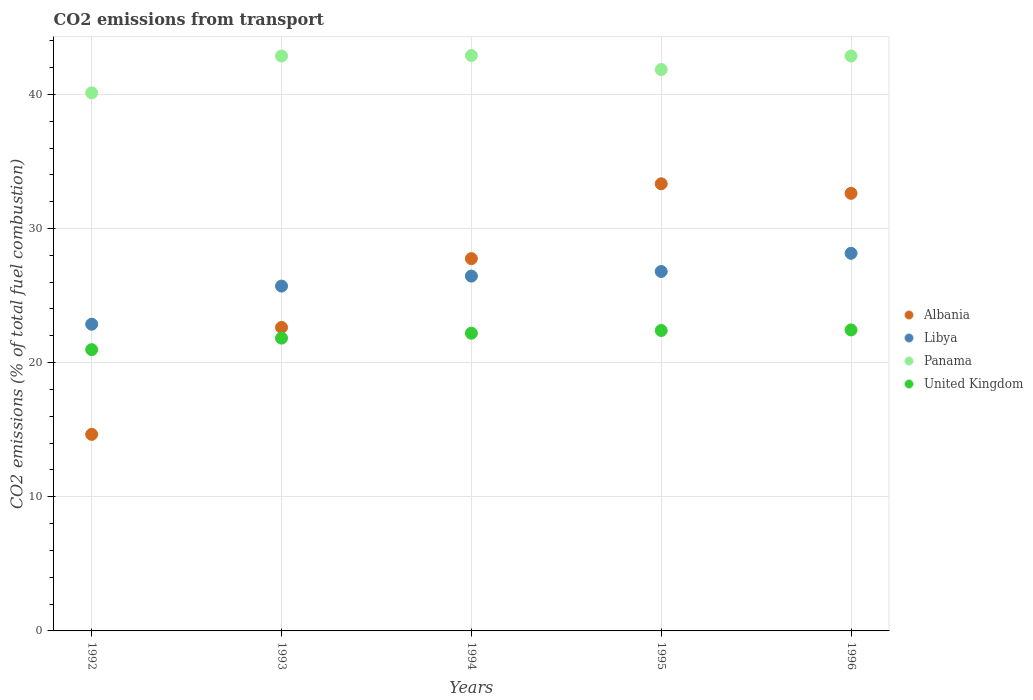What is the total CO2 emitted in Libya in 1994?
Offer a very short reply. 26.45. Across all years, what is the maximum total CO2 emitted in Albania?
Offer a terse response. 33.33. Across all years, what is the minimum total CO2 emitted in Panama?
Offer a terse response. 40.11. In which year was the total CO2 emitted in Libya maximum?
Ensure brevity in your answer.  1996. What is the total total CO2 emitted in Panama in the graph?
Give a very brief answer. 210.57. What is the difference between the total CO2 emitted in Libya in 1994 and that in 1996?
Make the answer very short. -1.7. What is the difference between the total CO2 emitted in Panama in 1993 and the total CO2 emitted in Albania in 1995?
Ensure brevity in your answer.  9.52. What is the average total CO2 emitted in United Kingdom per year?
Ensure brevity in your answer.  21.96. In the year 1992, what is the difference between the total CO2 emitted in United Kingdom and total CO2 emitted in Libya?
Your response must be concise. -1.9. What is the ratio of the total CO2 emitted in Panama in 1995 to that in 1996?
Keep it short and to the point. 0.98. Is the difference between the total CO2 emitted in United Kingdom in 1992 and 1995 greater than the difference between the total CO2 emitted in Libya in 1992 and 1995?
Provide a succinct answer. Yes. What is the difference between the highest and the second highest total CO2 emitted in Albania?
Your answer should be compact. 0.71. What is the difference between the highest and the lowest total CO2 emitted in Panama?
Offer a terse response. 2.78. Is it the case that in every year, the sum of the total CO2 emitted in United Kingdom and total CO2 emitted in Panama  is greater than the total CO2 emitted in Libya?
Your response must be concise. Yes. How many years are there in the graph?
Provide a short and direct response. 5. What is the difference between two consecutive major ticks on the Y-axis?
Your response must be concise. 10. Are the values on the major ticks of Y-axis written in scientific E-notation?
Provide a succinct answer. No. Does the graph contain grids?
Provide a short and direct response. Yes. How many legend labels are there?
Provide a short and direct response. 4. What is the title of the graph?
Keep it short and to the point. CO2 emissions from transport. Does "Canada" appear as one of the legend labels in the graph?
Make the answer very short. No. What is the label or title of the Y-axis?
Make the answer very short. CO2 emissions (% of total fuel combustion). What is the CO2 emissions (% of total fuel combustion) of Albania in 1992?
Your response must be concise. 14.65. What is the CO2 emissions (% of total fuel combustion) of Libya in 1992?
Your answer should be compact. 22.86. What is the CO2 emissions (% of total fuel combustion) of Panama in 1992?
Your answer should be very brief. 40.11. What is the CO2 emissions (% of total fuel combustion) in United Kingdom in 1992?
Make the answer very short. 20.97. What is the CO2 emissions (% of total fuel combustion) in Albania in 1993?
Give a very brief answer. 22.62. What is the CO2 emissions (% of total fuel combustion) of Libya in 1993?
Provide a short and direct response. 25.71. What is the CO2 emissions (% of total fuel combustion) of Panama in 1993?
Provide a succinct answer. 42.86. What is the CO2 emissions (% of total fuel combustion) of United Kingdom in 1993?
Your response must be concise. 21.83. What is the CO2 emissions (% of total fuel combustion) of Albania in 1994?
Ensure brevity in your answer.  27.75. What is the CO2 emissions (% of total fuel combustion) in Libya in 1994?
Offer a terse response. 26.45. What is the CO2 emissions (% of total fuel combustion) of Panama in 1994?
Offer a terse response. 42.89. What is the CO2 emissions (% of total fuel combustion) of United Kingdom in 1994?
Keep it short and to the point. 22.19. What is the CO2 emissions (% of total fuel combustion) in Albania in 1995?
Your response must be concise. 33.33. What is the CO2 emissions (% of total fuel combustion) in Libya in 1995?
Keep it short and to the point. 26.79. What is the CO2 emissions (% of total fuel combustion) of Panama in 1995?
Offer a very short reply. 41.85. What is the CO2 emissions (% of total fuel combustion) in United Kingdom in 1995?
Give a very brief answer. 22.4. What is the CO2 emissions (% of total fuel combustion) in Albania in 1996?
Ensure brevity in your answer.  32.62. What is the CO2 emissions (% of total fuel combustion) in Libya in 1996?
Provide a short and direct response. 28.15. What is the CO2 emissions (% of total fuel combustion) of Panama in 1996?
Give a very brief answer. 42.86. What is the CO2 emissions (% of total fuel combustion) in United Kingdom in 1996?
Make the answer very short. 22.44. Across all years, what is the maximum CO2 emissions (% of total fuel combustion) in Albania?
Offer a terse response. 33.33. Across all years, what is the maximum CO2 emissions (% of total fuel combustion) in Libya?
Offer a very short reply. 28.15. Across all years, what is the maximum CO2 emissions (% of total fuel combustion) of Panama?
Give a very brief answer. 42.89. Across all years, what is the maximum CO2 emissions (% of total fuel combustion) of United Kingdom?
Ensure brevity in your answer.  22.44. Across all years, what is the minimum CO2 emissions (% of total fuel combustion) in Albania?
Your answer should be very brief. 14.65. Across all years, what is the minimum CO2 emissions (% of total fuel combustion) in Libya?
Make the answer very short. 22.86. Across all years, what is the minimum CO2 emissions (% of total fuel combustion) of Panama?
Your answer should be compact. 40.11. Across all years, what is the minimum CO2 emissions (% of total fuel combustion) of United Kingdom?
Give a very brief answer. 20.97. What is the total CO2 emissions (% of total fuel combustion) of Albania in the graph?
Keep it short and to the point. 130.98. What is the total CO2 emissions (% of total fuel combustion) of Libya in the graph?
Provide a short and direct response. 129.97. What is the total CO2 emissions (% of total fuel combustion) of Panama in the graph?
Keep it short and to the point. 210.57. What is the total CO2 emissions (% of total fuel combustion) of United Kingdom in the graph?
Keep it short and to the point. 109.82. What is the difference between the CO2 emissions (% of total fuel combustion) of Albania in 1992 and that in 1993?
Keep it short and to the point. -7.97. What is the difference between the CO2 emissions (% of total fuel combustion) in Libya in 1992 and that in 1993?
Provide a short and direct response. -2.84. What is the difference between the CO2 emissions (% of total fuel combustion) of Panama in 1992 and that in 1993?
Your answer should be compact. -2.74. What is the difference between the CO2 emissions (% of total fuel combustion) of United Kingdom in 1992 and that in 1993?
Provide a succinct answer. -0.86. What is the difference between the CO2 emissions (% of total fuel combustion) of Albania in 1992 and that in 1994?
Offer a terse response. -13.1. What is the difference between the CO2 emissions (% of total fuel combustion) in Libya in 1992 and that in 1994?
Your answer should be very brief. -3.59. What is the difference between the CO2 emissions (% of total fuel combustion) of Panama in 1992 and that in 1994?
Your answer should be compact. -2.78. What is the difference between the CO2 emissions (% of total fuel combustion) in United Kingdom in 1992 and that in 1994?
Your answer should be very brief. -1.23. What is the difference between the CO2 emissions (% of total fuel combustion) of Albania in 1992 and that in 1995?
Your answer should be very brief. -18.68. What is the difference between the CO2 emissions (% of total fuel combustion) of Libya in 1992 and that in 1995?
Your response must be concise. -3.93. What is the difference between the CO2 emissions (% of total fuel combustion) of Panama in 1992 and that in 1995?
Keep it short and to the point. -1.74. What is the difference between the CO2 emissions (% of total fuel combustion) of United Kingdom in 1992 and that in 1995?
Provide a succinct answer. -1.43. What is the difference between the CO2 emissions (% of total fuel combustion) of Albania in 1992 and that in 1996?
Provide a short and direct response. -17.97. What is the difference between the CO2 emissions (% of total fuel combustion) in Libya in 1992 and that in 1996?
Your response must be concise. -5.29. What is the difference between the CO2 emissions (% of total fuel combustion) of Panama in 1992 and that in 1996?
Your response must be concise. -2.74. What is the difference between the CO2 emissions (% of total fuel combustion) in United Kingdom in 1992 and that in 1996?
Your response must be concise. -1.47. What is the difference between the CO2 emissions (% of total fuel combustion) of Albania in 1993 and that in 1994?
Make the answer very short. -5.13. What is the difference between the CO2 emissions (% of total fuel combustion) in Libya in 1993 and that in 1994?
Provide a succinct answer. -0.74. What is the difference between the CO2 emissions (% of total fuel combustion) of Panama in 1993 and that in 1994?
Provide a succinct answer. -0.04. What is the difference between the CO2 emissions (% of total fuel combustion) in United Kingdom in 1993 and that in 1994?
Give a very brief answer. -0.37. What is the difference between the CO2 emissions (% of total fuel combustion) of Albania in 1993 and that in 1995?
Your response must be concise. -10.71. What is the difference between the CO2 emissions (% of total fuel combustion) of Libya in 1993 and that in 1995?
Offer a very short reply. -1.09. What is the difference between the CO2 emissions (% of total fuel combustion) of United Kingdom in 1993 and that in 1995?
Ensure brevity in your answer.  -0.57. What is the difference between the CO2 emissions (% of total fuel combustion) of Albania in 1993 and that in 1996?
Your response must be concise. -10. What is the difference between the CO2 emissions (% of total fuel combustion) in Libya in 1993 and that in 1996?
Your answer should be very brief. -2.44. What is the difference between the CO2 emissions (% of total fuel combustion) of United Kingdom in 1993 and that in 1996?
Give a very brief answer. -0.61. What is the difference between the CO2 emissions (% of total fuel combustion) in Albania in 1994 and that in 1995?
Make the answer very short. -5.58. What is the difference between the CO2 emissions (% of total fuel combustion) of Libya in 1994 and that in 1995?
Give a very brief answer. -0.34. What is the difference between the CO2 emissions (% of total fuel combustion) in Panama in 1994 and that in 1995?
Provide a short and direct response. 1.05. What is the difference between the CO2 emissions (% of total fuel combustion) in United Kingdom in 1994 and that in 1995?
Your answer should be compact. -0.2. What is the difference between the CO2 emissions (% of total fuel combustion) in Albania in 1994 and that in 1996?
Offer a very short reply. -4.87. What is the difference between the CO2 emissions (% of total fuel combustion) of Libya in 1994 and that in 1996?
Keep it short and to the point. -1.7. What is the difference between the CO2 emissions (% of total fuel combustion) in Panama in 1994 and that in 1996?
Give a very brief answer. 0.04. What is the difference between the CO2 emissions (% of total fuel combustion) in United Kingdom in 1994 and that in 1996?
Offer a very short reply. -0.25. What is the difference between the CO2 emissions (% of total fuel combustion) in Albania in 1995 and that in 1996?
Offer a terse response. 0.71. What is the difference between the CO2 emissions (% of total fuel combustion) in Libya in 1995 and that in 1996?
Give a very brief answer. -1.36. What is the difference between the CO2 emissions (% of total fuel combustion) in Panama in 1995 and that in 1996?
Provide a short and direct response. -1.01. What is the difference between the CO2 emissions (% of total fuel combustion) of United Kingdom in 1995 and that in 1996?
Ensure brevity in your answer.  -0.04. What is the difference between the CO2 emissions (% of total fuel combustion) of Albania in 1992 and the CO2 emissions (% of total fuel combustion) of Libya in 1993?
Your answer should be very brief. -11.06. What is the difference between the CO2 emissions (% of total fuel combustion) in Albania in 1992 and the CO2 emissions (% of total fuel combustion) in Panama in 1993?
Keep it short and to the point. -28.21. What is the difference between the CO2 emissions (% of total fuel combustion) in Albania in 1992 and the CO2 emissions (% of total fuel combustion) in United Kingdom in 1993?
Your answer should be very brief. -7.17. What is the difference between the CO2 emissions (% of total fuel combustion) of Libya in 1992 and the CO2 emissions (% of total fuel combustion) of Panama in 1993?
Make the answer very short. -19.99. What is the difference between the CO2 emissions (% of total fuel combustion) of Libya in 1992 and the CO2 emissions (% of total fuel combustion) of United Kingdom in 1993?
Offer a terse response. 1.04. What is the difference between the CO2 emissions (% of total fuel combustion) in Panama in 1992 and the CO2 emissions (% of total fuel combustion) in United Kingdom in 1993?
Give a very brief answer. 18.29. What is the difference between the CO2 emissions (% of total fuel combustion) in Albania in 1992 and the CO2 emissions (% of total fuel combustion) in Libya in 1994?
Provide a succinct answer. -11.8. What is the difference between the CO2 emissions (% of total fuel combustion) in Albania in 1992 and the CO2 emissions (% of total fuel combustion) in Panama in 1994?
Your answer should be very brief. -28.24. What is the difference between the CO2 emissions (% of total fuel combustion) of Albania in 1992 and the CO2 emissions (% of total fuel combustion) of United Kingdom in 1994?
Provide a short and direct response. -7.54. What is the difference between the CO2 emissions (% of total fuel combustion) of Libya in 1992 and the CO2 emissions (% of total fuel combustion) of Panama in 1994?
Ensure brevity in your answer.  -20.03. What is the difference between the CO2 emissions (% of total fuel combustion) in Libya in 1992 and the CO2 emissions (% of total fuel combustion) in United Kingdom in 1994?
Keep it short and to the point. 0.67. What is the difference between the CO2 emissions (% of total fuel combustion) of Panama in 1992 and the CO2 emissions (% of total fuel combustion) of United Kingdom in 1994?
Your response must be concise. 17.92. What is the difference between the CO2 emissions (% of total fuel combustion) in Albania in 1992 and the CO2 emissions (% of total fuel combustion) in Libya in 1995?
Ensure brevity in your answer.  -12.14. What is the difference between the CO2 emissions (% of total fuel combustion) in Albania in 1992 and the CO2 emissions (% of total fuel combustion) in Panama in 1995?
Provide a short and direct response. -27.2. What is the difference between the CO2 emissions (% of total fuel combustion) of Albania in 1992 and the CO2 emissions (% of total fuel combustion) of United Kingdom in 1995?
Ensure brevity in your answer.  -7.74. What is the difference between the CO2 emissions (% of total fuel combustion) in Libya in 1992 and the CO2 emissions (% of total fuel combustion) in Panama in 1995?
Keep it short and to the point. -18.99. What is the difference between the CO2 emissions (% of total fuel combustion) in Libya in 1992 and the CO2 emissions (% of total fuel combustion) in United Kingdom in 1995?
Your answer should be compact. 0.47. What is the difference between the CO2 emissions (% of total fuel combustion) of Panama in 1992 and the CO2 emissions (% of total fuel combustion) of United Kingdom in 1995?
Make the answer very short. 17.72. What is the difference between the CO2 emissions (% of total fuel combustion) in Albania in 1992 and the CO2 emissions (% of total fuel combustion) in Libya in 1996?
Provide a succinct answer. -13.5. What is the difference between the CO2 emissions (% of total fuel combustion) in Albania in 1992 and the CO2 emissions (% of total fuel combustion) in Panama in 1996?
Offer a very short reply. -28.21. What is the difference between the CO2 emissions (% of total fuel combustion) in Albania in 1992 and the CO2 emissions (% of total fuel combustion) in United Kingdom in 1996?
Your response must be concise. -7.79. What is the difference between the CO2 emissions (% of total fuel combustion) in Libya in 1992 and the CO2 emissions (% of total fuel combustion) in Panama in 1996?
Your response must be concise. -19.99. What is the difference between the CO2 emissions (% of total fuel combustion) in Libya in 1992 and the CO2 emissions (% of total fuel combustion) in United Kingdom in 1996?
Provide a succinct answer. 0.42. What is the difference between the CO2 emissions (% of total fuel combustion) in Panama in 1992 and the CO2 emissions (% of total fuel combustion) in United Kingdom in 1996?
Give a very brief answer. 17.67. What is the difference between the CO2 emissions (% of total fuel combustion) of Albania in 1993 and the CO2 emissions (% of total fuel combustion) of Libya in 1994?
Make the answer very short. -3.83. What is the difference between the CO2 emissions (% of total fuel combustion) in Albania in 1993 and the CO2 emissions (% of total fuel combustion) in Panama in 1994?
Provide a succinct answer. -20.27. What is the difference between the CO2 emissions (% of total fuel combustion) in Albania in 1993 and the CO2 emissions (% of total fuel combustion) in United Kingdom in 1994?
Offer a terse response. 0.43. What is the difference between the CO2 emissions (% of total fuel combustion) in Libya in 1993 and the CO2 emissions (% of total fuel combustion) in Panama in 1994?
Provide a short and direct response. -17.19. What is the difference between the CO2 emissions (% of total fuel combustion) in Libya in 1993 and the CO2 emissions (% of total fuel combustion) in United Kingdom in 1994?
Your response must be concise. 3.51. What is the difference between the CO2 emissions (% of total fuel combustion) of Panama in 1993 and the CO2 emissions (% of total fuel combustion) of United Kingdom in 1994?
Provide a short and direct response. 20.66. What is the difference between the CO2 emissions (% of total fuel combustion) of Albania in 1993 and the CO2 emissions (% of total fuel combustion) of Libya in 1995?
Offer a very short reply. -4.17. What is the difference between the CO2 emissions (% of total fuel combustion) of Albania in 1993 and the CO2 emissions (% of total fuel combustion) of Panama in 1995?
Provide a short and direct response. -19.22. What is the difference between the CO2 emissions (% of total fuel combustion) in Albania in 1993 and the CO2 emissions (% of total fuel combustion) in United Kingdom in 1995?
Provide a short and direct response. 0.23. What is the difference between the CO2 emissions (% of total fuel combustion) in Libya in 1993 and the CO2 emissions (% of total fuel combustion) in Panama in 1995?
Your answer should be compact. -16.14. What is the difference between the CO2 emissions (% of total fuel combustion) in Libya in 1993 and the CO2 emissions (% of total fuel combustion) in United Kingdom in 1995?
Your answer should be very brief. 3.31. What is the difference between the CO2 emissions (% of total fuel combustion) of Panama in 1993 and the CO2 emissions (% of total fuel combustion) of United Kingdom in 1995?
Your response must be concise. 20.46. What is the difference between the CO2 emissions (% of total fuel combustion) of Albania in 1993 and the CO2 emissions (% of total fuel combustion) of Libya in 1996?
Offer a very short reply. -5.53. What is the difference between the CO2 emissions (% of total fuel combustion) in Albania in 1993 and the CO2 emissions (% of total fuel combustion) in Panama in 1996?
Provide a succinct answer. -20.23. What is the difference between the CO2 emissions (% of total fuel combustion) in Albania in 1993 and the CO2 emissions (% of total fuel combustion) in United Kingdom in 1996?
Offer a very short reply. 0.18. What is the difference between the CO2 emissions (% of total fuel combustion) in Libya in 1993 and the CO2 emissions (% of total fuel combustion) in Panama in 1996?
Ensure brevity in your answer.  -17.15. What is the difference between the CO2 emissions (% of total fuel combustion) of Libya in 1993 and the CO2 emissions (% of total fuel combustion) of United Kingdom in 1996?
Ensure brevity in your answer.  3.27. What is the difference between the CO2 emissions (% of total fuel combustion) of Panama in 1993 and the CO2 emissions (% of total fuel combustion) of United Kingdom in 1996?
Your answer should be compact. 20.42. What is the difference between the CO2 emissions (% of total fuel combustion) of Albania in 1994 and the CO2 emissions (% of total fuel combustion) of Libya in 1995?
Keep it short and to the point. 0.96. What is the difference between the CO2 emissions (% of total fuel combustion) in Albania in 1994 and the CO2 emissions (% of total fuel combustion) in Panama in 1995?
Your response must be concise. -14.1. What is the difference between the CO2 emissions (% of total fuel combustion) of Albania in 1994 and the CO2 emissions (% of total fuel combustion) of United Kingdom in 1995?
Your response must be concise. 5.36. What is the difference between the CO2 emissions (% of total fuel combustion) in Libya in 1994 and the CO2 emissions (% of total fuel combustion) in Panama in 1995?
Your answer should be compact. -15.4. What is the difference between the CO2 emissions (% of total fuel combustion) of Libya in 1994 and the CO2 emissions (% of total fuel combustion) of United Kingdom in 1995?
Your answer should be compact. 4.05. What is the difference between the CO2 emissions (% of total fuel combustion) of Panama in 1994 and the CO2 emissions (% of total fuel combustion) of United Kingdom in 1995?
Your answer should be very brief. 20.5. What is the difference between the CO2 emissions (% of total fuel combustion) in Albania in 1994 and the CO2 emissions (% of total fuel combustion) in Libya in 1996?
Make the answer very short. -0.4. What is the difference between the CO2 emissions (% of total fuel combustion) of Albania in 1994 and the CO2 emissions (% of total fuel combustion) of Panama in 1996?
Provide a short and direct response. -15.1. What is the difference between the CO2 emissions (% of total fuel combustion) in Albania in 1994 and the CO2 emissions (% of total fuel combustion) in United Kingdom in 1996?
Your response must be concise. 5.31. What is the difference between the CO2 emissions (% of total fuel combustion) in Libya in 1994 and the CO2 emissions (% of total fuel combustion) in Panama in 1996?
Give a very brief answer. -16.41. What is the difference between the CO2 emissions (% of total fuel combustion) in Libya in 1994 and the CO2 emissions (% of total fuel combustion) in United Kingdom in 1996?
Make the answer very short. 4.01. What is the difference between the CO2 emissions (% of total fuel combustion) of Panama in 1994 and the CO2 emissions (% of total fuel combustion) of United Kingdom in 1996?
Give a very brief answer. 20.46. What is the difference between the CO2 emissions (% of total fuel combustion) of Albania in 1995 and the CO2 emissions (% of total fuel combustion) of Libya in 1996?
Provide a short and direct response. 5.18. What is the difference between the CO2 emissions (% of total fuel combustion) of Albania in 1995 and the CO2 emissions (% of total fuel combustion) of Panama in 1996?
Offer a terse response. -9.52. What is the difference between the CO2 emissions (% of total fuel combustion) of Albania in 1995 and the CO2 emissions (% of total fuel combustion) of United Kingdom in 1996?
Provide a succinct answer. 10.89. What is the difference between the CO2 emissions (% of total fuel combustion) of Libya in 1995 and the CO2 emissions (% of total fuel combustion) of Panama in 1996?
Make the answer very short. -16.06. What is the difference between the CO2 emissions (% of total fuel combustion) of Libya in 1995 and the CO2 emissions (% of total fuel combustion) of United Kingdom in 1996?
Your answer should be compact. 4.35. What is the difference between the CO2 emissions (% of total fuel combustion) in Panama in 1995 and the CO2 emissions (% of total fuel combustion) in United Kingdom in 1996?
Offer a very short reply. 19.41. What is the average CO2 emissions (% of total fuel combustion) in Albania per year?
Offer a very short reply. 26.2. What is the average CO2 emissions (% of total fuel combustion) of Libya per year?
Give a very brief answer. 25.99. What is the average CO2 emissions (% of total fuel combustion) of Panama per year?
Ensure brevity in your answer.  42.11. What is the average CO2 emissions (% of total fuel combustion) in United Kingdom per year?
Your answer should be very brief. 21.96. In the year 1992, what is the difference between the CO2 emissions (% of total fuel combustion) in Albania and CO2 emissions (% of total fuel combustion) in Libya?
Your answer should be very brief. -8.21. In the year 1992, what is the difference between the CO2 emissions (% of total fuel combustion) of Albania and CO2 emissions (% of total fuel combustion) of Panama?
Your response must be concise. -25.46. In the year 1992, what is the difference between the CO2 emissions (% of total fuel combustion) of Albania and CO2 emissions (% of total fuel combustion) of United Kingdom?
Your answer should be compact. -6.31. In the year 1992, what is the difference between the CO2 emissions (% of total fuel combustion) in Libya and CO2 emissions (% of total fuel combustion) in Panama?
Make the answer very short. -17.25. In the year 1992, what is the difference between the CO2 emissions (% of total fuel combustion) in Libya and CO2 emissions (% of total fuel combustion) in United Kingdom?
Your response must be concise. 1.9. In the year 1992, what is the difference between the CO2 emissions (% of total fuel combustion) of Panama and CO2 emissions (% of total fuel combustion) of United Kingdom?
Your response must be concise. 19.15. In the year 1993, what is the difference between the CO2 emissions (% of total fuel combustion) of Albania and CO2 emissions (% of total fuel combustion) of Libya?
Your answer should be very brief. -3.08. In the year 1993, what is the difference between the CO2 emissions (% of total fuel combustion) in Albania and CO2 emissions (% of total fuel combustion) in Panama?
Your answer should be very brief. -20.23. In the year 1993, what is the difference between the CO2 emissions (% of total fuel combustion) of Albania and CO2 emissions (% of total fuel combustion) of United Kingdom?
Your answer should be compact. 0.8. In the year 1993, what is the difference between the CO2 emissions (% of total fuel combustion) in Libya and CO2 emissions (% of total fuel combustion) in Panama?
Your answer should be very brief. -17.15. In the year 1993, what is the difference between the CO2 emissions (% of total fuel combustion) of Libya and CO2 emissions (% of total fuel combustion) of United Kingdom?
Provide a succinct answer. 3.88. In the year 1993, what is the difference between the CO2 emissions (% of total fuel combustion) in Panama and CO2 emissions (% of total fuel combustion) in United Kingdom?
Keep it short and to the point. 21.03. In the year 1994, what is the difference between the CO2 emissions (% of total fuel combustion) of Albania and CO2 emissions (% of total fuel combustion) of Libya?
Provide a short and direct response. 1.3. In the year 1994, what is the difference between the CO2 emissions (% of total fuel combustion) in Albania and CO2 emissions (% of total fuel combustion) in Panama?
Provide a short and direct response. -15.14. In the year 1994, what is the difference between the CO2 emissions (% of total fuel combustion) in Albania and CO2 emissions (% of total fuel combustion) in United Kingdom?
Provide a short and direct response. 5.56. In the year 1994, what is the difference between the CO2 emissions (% of total fuel combustion) of Libya and CO2 emissions (% of total fuel combustion) of Panama?
Ensure brevity in your answer.  -16.44. In the year 1994, what is the difference between the CO2 emissions (% of total fuel combustion) of Libya and CO2 emissions (% of total fuel combustion) of United Kingdom?
Offer a very short reply. 4.26. In the year 1994, what is the difference between the CO2 emissions (% of total fuel combustion) of Panama and CO2 emissions (% of total fuel combustion) of United Kingdom?
Your response must be concise. 20.7. In the year 1995, what is the difference between the CO2 emissions (% of total fuel combustion) in Albania and CO2 emissions (% of total fuel combustion) in Libya?
Make the answer very short. 6.54. In the year 1995, what is the difference between the CO2 emissions (% of total fuel combustion) of Albania and CO2 emissions (% of total fuel combustion) of Panama?
Your answer should be very brief. -8.52. In the year 1995, what is the difference between the CO2 emissions (% of total fuel combustion) in Albania and CO2 emissions (% of total fuel combustion) in United Kingdom?
Your response must be concise. 10.94. In the year 1995, what is the difference between the CO2 emissions (% of total fuel combustion) in Libya and CO2 emissions (% of total fuel combustion) in Panama?
Provide a short and direct response. -15.06. In the year 1995, what is the difference between the CO2 emissions (% of total fuel combustion) in Libya and CO2 emissions (% of total fuel combustion) in United Kingdom?
Provide a succinct answer. 4.4. In the year 1995, what is the difference between the CO2 emissions (% of total fuel combustion) of Panama and CO2 emissions (% of total fuel combustion) of United Kingdom?
Ensure brevity in your answer.  19.45. In the year 1996, what is the difference between the CO2 emissions (% of total fuel combustion) in Albania and CO2 emissions (% of total fuel combustion) in Libya?
Your answer should be very brief. 4.47. In the year 1996, what is the difference between the CO2 emissions (% of total fuel combustion) of Albania and CO2 emissions (% of total fuel combustion) of Panama?
Your answer should be very brief. -10.24. In the year 1996, what is the difference between the CO2 emissions (% of total fuel combustion) of Albania and CO2 emissions (% of total fuel combustion) of United Kingdom?
Your response must be concise. 10.18. In the year 1996, what is the difference between the CO2 emissions (% of total fuel combustion) in Libya and CO2 emissions (% of total fuel combustion) in Panama?
Your answer should be compact. -14.71. In the year 1996, what is the difference between the CO2 emissions (% of total fuel combustion) in Libya and CO2 emissions (% of total fuel combustion) in United Kingdom?
Provide a succinct answer. 5.71. In the year 1996, what is the difference between the CO2 emissions (% of total fuel combustion) of Panama and CO2 emissions (% of total fuel combustion) of United Kingdom?
Keep it short and to the point. 20.42. What is the ratio of the CO2 emissions (% of total fuel combustion) of Albania in 1992 to that in 1993?
Offer a terse response. 0.65. What is the ratio of the CO2 emissions (% of total fuel combustion) of Libya in 1992 to that in 1993?
Give a very brief answer. 0.89. What is the ratio of the CO2 emissions (% of total fuel combustion) of Panama in 1992 to that in 1993?
Offer a terse response. 0.94. What is the ratio of the CO2 emissions (% of total fuel combustion) of United Kingdom in 1992 to that in 1993?
Offer a terse response. 0.96. What is the ratio of the CO2 emissions (% of total fuel combustion) in Albania in 1992 to that in 1994?
Keep it short and to the point. 0.53. What is the ratio of the CO2 emissions (% of total fuel combustion) in Libya in 1992 to that in 1994?
Offer a terse response. 0.86. What is the ratio of the CO2 emissions (% of total fuel combustion) in Panama in 1992 to that in 1994?
Offer a very short reply. 0.94. What is the ratio of the CO2 emissions (% of total fuel combustion) of United Kingdom in 1992 to that in 1994?
Provide a succinct answer. 0.94. What is the ratio of the CO2 emissions (% of total fuel combustion) in Albania in 1992 to that in 1995?
Offer a very short reply. 0.44. What is the ratio of the CO2 emissions (% of total fuel combustion) in Libya in 1992 to that in 1995?
Offer a very short reply. 0.85. What is the ratio of the CO2 emissions (% of total fuel combustion) in Panama in 1992 to that in 1995?
Your answer should be compact. 0.96. What is the ratio of the CO2 emissions (% of total fuel combustion) in United Kingdom in 1992 to that in 1995?
Your response must be concise. 0.94. What is the ratio of the CO2 emissions (% of total fuel combustion) in Albania in 1992 to that in 1996?
Keep it short and to the point. 0.45. What is the ratio of the CO2 emissions (% of total fuel combustion) of Libya in 1992 to that in 1996?
Ensure brevity in your answer.  0.81. What is the ratio of the CO2 emissions (% of total fuel combustion) of Panama in 1992 to that in 1996?
Keep it short and to the point. 0.94. What is the ratio of the CO2 emissions (% of total fuel combustion) in United Kingdom in 1992 to that in 1996?
Offer a very short reply. 0.93. What is the ratio of the CO2 emissions (% of total fuel combustion) in Albania in 1993 to that in 1994?
Make the answer very short. 0.82. What is the ratio of the CO2 emissions (% of total fuel combustion) of Libya in 1993 to that in 1994?
Keep it short and to the point. 0.97. What is the ratio of the CO2 emissions (% of total fuel combustion) of United Kingdom in 1993 to that in 1994?
Provide a succinct answer. 0.98. What is the ratio of the CO2 emissions (% of total fuel combustion) of Albania in 1993 to that in 1995?
Provide a succinct answer. 0.68. What is the ratio of the CO2 emissions (% of total fuel combustion) in Libya in 1993 to that in 1995?
Offer a very short reply. 0.96. What is the ratio of the CO2 emissions (% of total fuel combustion) in Panama in 1993 to that in 1995?
Ensure brevity in your answer.  1.02. What is the ratio of the CO2 emissions (% of total fuel combustion) of United Kingdom in 1993 to that in 1995?
Offer a very short reply. 0.97. What is the ratio of the CO2 emissions (% of total fuel combustion) of Albania in 1993 to that in 1996?
Give a very brief answer. 0.69. What is the ratio of the CO2 emissions (% of total fuel combustion) of Libya in 1993 to that in 1996?
Ensure brevity in your answer.  0.91. What is the ratio of the CO2 emissions (% of total fuel combustion) in Panama in 1993 to that in 1996?
Offer a very short reply. 1. What is the ratio of the CO2 emissions (% of total fuel combustion) in United Kingdom in 1993 to that in 1996?
Provide a short and direct response. 0.97. What is the ratio of the CO2 emissions (% of total fuel combustion) in Albania in 1994 to that in 1995?
Give a very brief answer. 0.83. What is the ratio of the CO2 emissions (% of total fuel combustion) in Libya in 1994 to that in 1995?
Give a very brief answer. 0.99. What is the ratio of the CO2 emissions (% of total fuel combustion) of Panama in 1994 to that in 1995?
Your answer should be very brief. 1.02. What is the ratio of the CO2 emissions (% of total fuel combustion) of United Kingdom in 1994 to that in 1995?
Offer a very short reply. 0.99. What is the ratio of the CO2 emissions (% of total fuel combustion) in Albania in 1994 to that in 1996?
Your answer should be very brief. 0.85. What is the ratio of the CO2 emissions (% of total fuel combustion) of Libya in 1994 to that in 1996?
Make the answer very short. 0.94. What is the ratio of the CO2 emissions (% of total fuel combustion) in Panama in 1994 to that in 1996?
Make the answer very short. 1. What is the ratio of the CO2 emissions (% of total fuel combustion) of Albania in 1995 to that in 1996?
Your answer should be very brief. 1.02. What is the ratio of the CO2 emissions (% of total fuel combustion) of Libya in 1995 to that in 1996?
Your answer should be compact. 0.95. What is the ratio of the CO2 emissions (% of total fuel combustion) in Panama in 1995 to that in 1996?
Keep it short and to the point. 0.98. What is the difference between the highest and the second highest CO2 emissions (% of total fuel combustion) of Albania?
Offer a terse response. 0.71. What is the difference between the highest and the second highest CO2 emissions (% of total fuel combustion) in Libya?
Your answer should be compact. 1.36. What is the difference between the highest and the second highest CO2 emissions (% of total fuel combustion) in Panama?
Your answer should be very brief. 0.04. What is the difference between the highest and the second highest CO2 emissions (% of total fuel combustion) in United Kingdom?
Offer a very short reply. 0.04. What is the difference between the highest and the lowest CO2 emissions (% of total fuel combustion) of Albania?
Provide a short and direct response. 18.68. What is the difference between the highest and the lowest CO2 emissions (% of total fuel combustion) of Libya?
Give a very brief answer. 5.29. What is the difference between the highest and the lowest CO2 emissions (% of total fuel combustion) of Panama?
Ensure brevity in your answer.  2.78. What is the difference between the highest and the lowest CO2 emissions (% of total fuel combustion) in United Kingdom?
Provide a succinct answer. 1.47. 